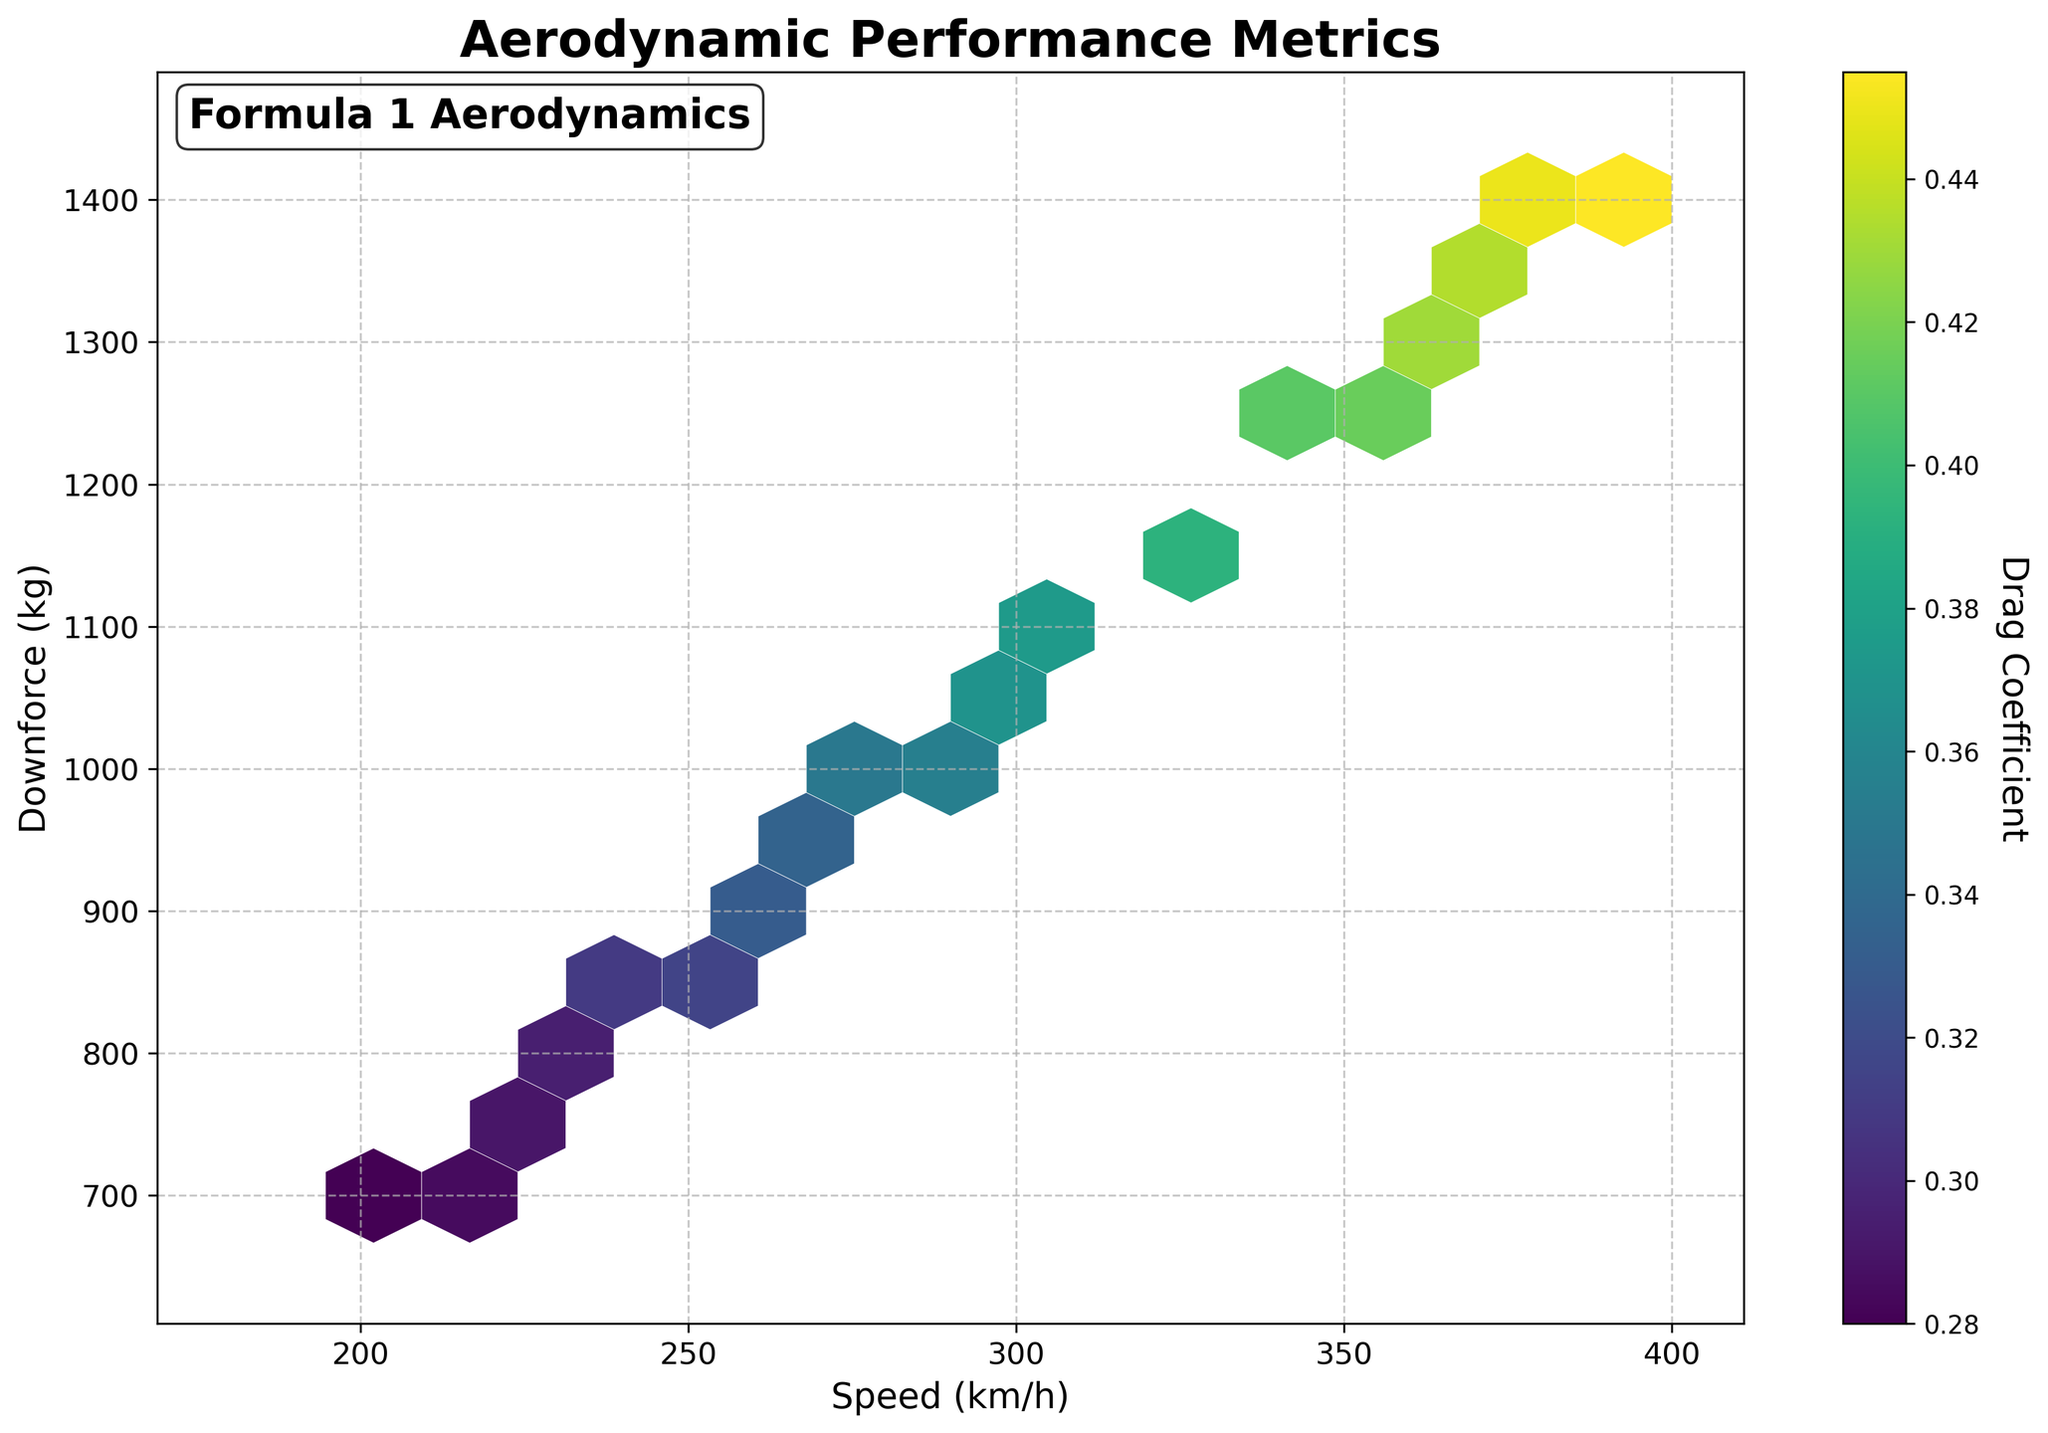what is the title of the plot? The title is written at the top of the plot to give an overview of what the data represents. For this plot, it is "Aerodynamic Performance Metrics".
Answer: Aerodynamic Performance Metrics what do the x and y axes represent? The labels along the x and y axes indicate the variables being plotted. The x-axis represents Speed in km/h, and the y-axis represents Downforce in kg.
Answer: Speed (km/h) and Downforce (kg) how is the drag coefficient represented in this plot? The Drag Coefficient is shown using the color intensity in the hexagonal bins, with a color bar on the right indicating the specific values.
Answer: Color intensity in hexagonal bins what is the range of speeds displayed in the plot? To determine the range of speeds, observe the x-axis. The speeds range from 200 km/h to 380 km/h.
Answer: 200 km/h to 380 km/h which region of the plot has the highest downforce values? The highest downforce values would be represented towards the upper part of the plot, on the y-axis. Hence, bins farther up on the y-axis close to 1400 kg show the highest downforce.
Answer: Upper part of the plot does temperature affect the color intensity for specific speeds and downforce values? The plot does not directly display temperature; hence we cannot determine its impact on color intensity or drag coefficient directly from this plot.
Answer: Cannot determine from the plot how can the color bar be used to interpret data points? The color bar shows the range of drag coefficients with corresponding colors. By matching the color of a hexagonal bin to the color bar, we can identify the drag coefficient for that region.
Answer: Match hexagonal color to the color bar what speed and downforce combinations result in the highest drag coefficient? Observe the darkest regions (higher values) of the color intensity and reference the axes. High drag coefficients are found around higher speeds (e.g., 380 km/h) and high downforce values (e.g., 1380 kg).
Answer: Around 380 km/h and 1380 kg how does the downforce generally change with increasing speed? Based on the plot's general trend, as speed increases along the x-axis, downforce values on the y-axis also increase.
Answer: Downforce increases with increasing speed is there a specific speed range where the drag coefficient changes more significantly? The color intensity shows the changes. A significant color change is observed between 300 km/h and 380 km/h, indicating a notable change in drag coefficients within this range.
Answer: Between 300 km/h and 380 km/h 